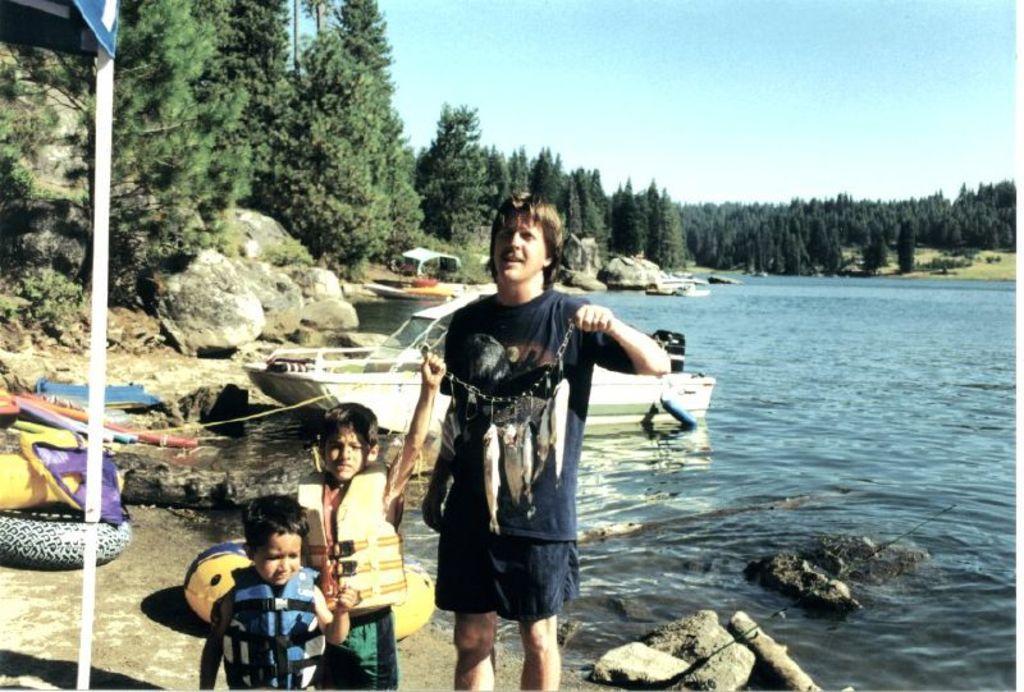Please provide a concise description of this image. In this image we can see this person wearing blue t-shirt and these two children wearing life jackets are holding fishes which are tired to the chain. Here we can see the pole, we can see the tubes, boats floating in the water, we can see rocks, trees and sky in the background. 